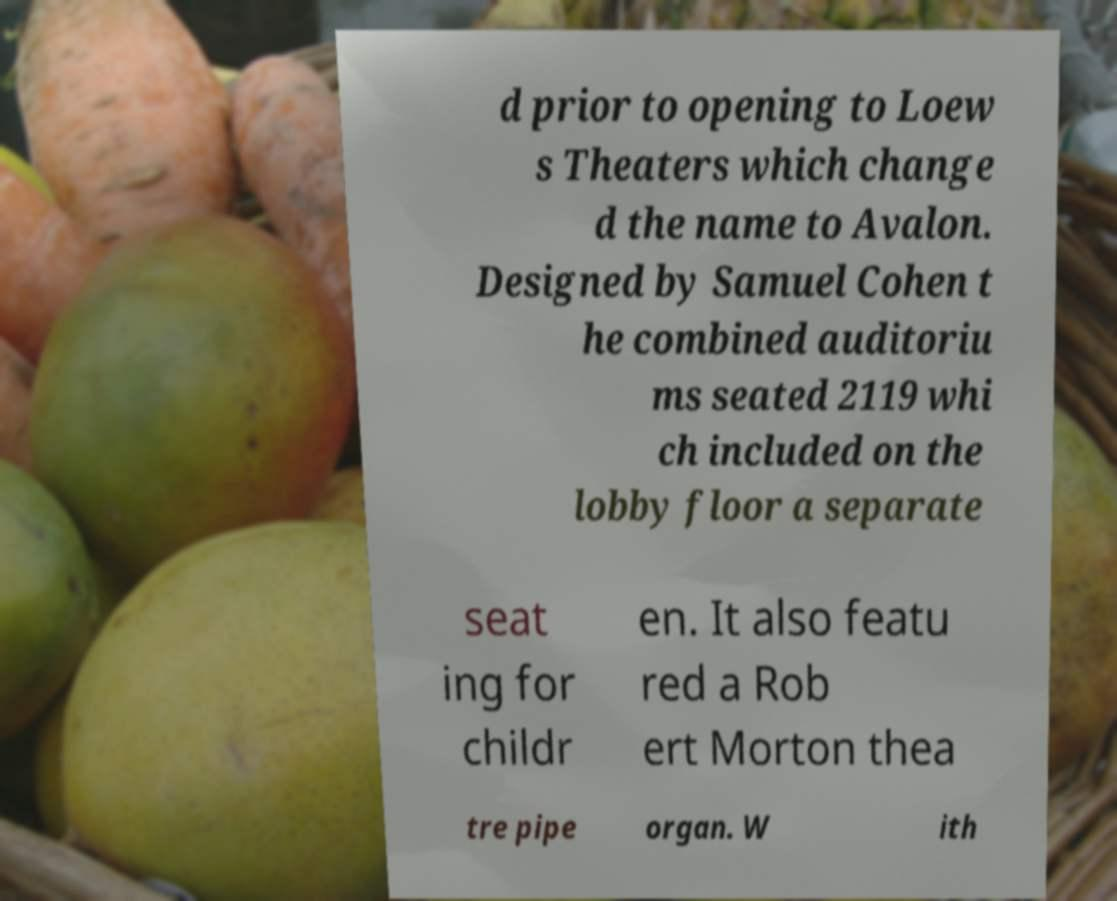Please read and relay the text visible in this image. What does it say? d prior to opening to Loew s Theaters which change d the name to Avalon. Designed by Samuel Cohen t he combined auditoriu ms seated 2119 whi ch included on the lobby floor a separate seat ing for childr en. It also featu red a Rob ert Morton thea tre pipe organ. W ith 